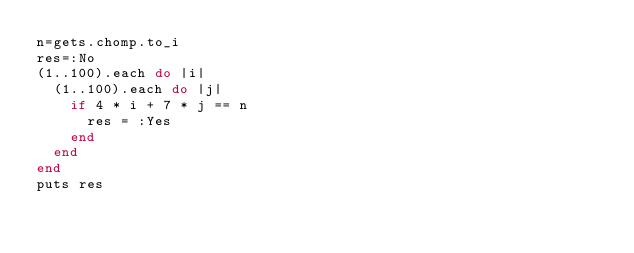<code> <loc_0><loc_0><loc_500><loc_500><_Ruby_>n=gets.chomp.to_i
res=:No
(1..100).each do |i|
  (1..100).each do |j|
    if 4 * i + 7 * j == n
      res = :Yes
    end
  end
end
puts res</code> 